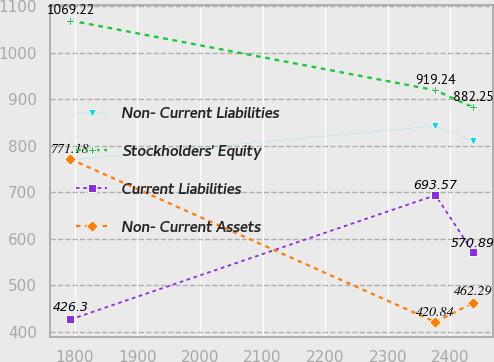Convert chart. <chart><loc_0><loc_0><loc_500><loc_500><line_chart><ecel><fcel>Non- Current Liabilities<fcel>Stockholders' Equity<fcel>Current Liabilities<fcel>Non- Current Assets<nl><fcel>1793.16<fcel>769.57<fcel>1069.22<fcel>426.3<fcel>771.18<nl><fcel>2376.03<fcel>842.59<fcel>919.24<fcel>693.57<fcel>420.84<nl><fcel>2436.23<fcel>809.57<fcel>882.25<fcel>570.89<fcel>462.29<nl></chart> 